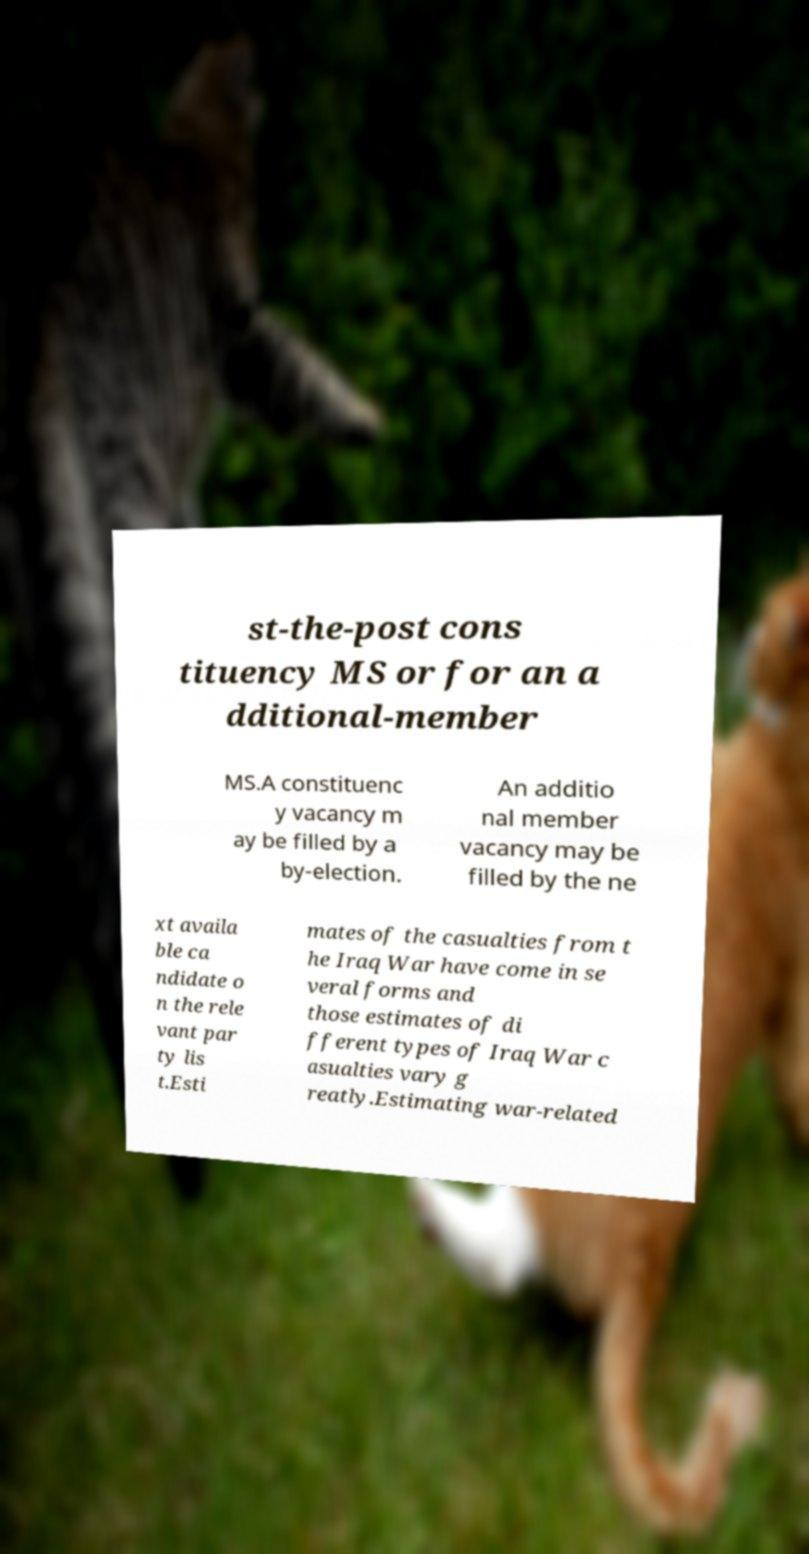Can you read and provide the text displayed in the image?This photo seems to have some interesting text. Can you extract and type it out for me? st-the-post cons tituency MS or for an a dditional-member MS.A constituenc y vacancy m ay be filled by a by-election. An additio nal member vacancy may be filled by the ne xt availa ble ca ndidate o n the rele vant par ty lis t.Esti mates of the casualties from t he Iraq War have come in se veral forms and those estimates of di fferent types of Iraq War c asualties vary g reatly.Estimating war-related 